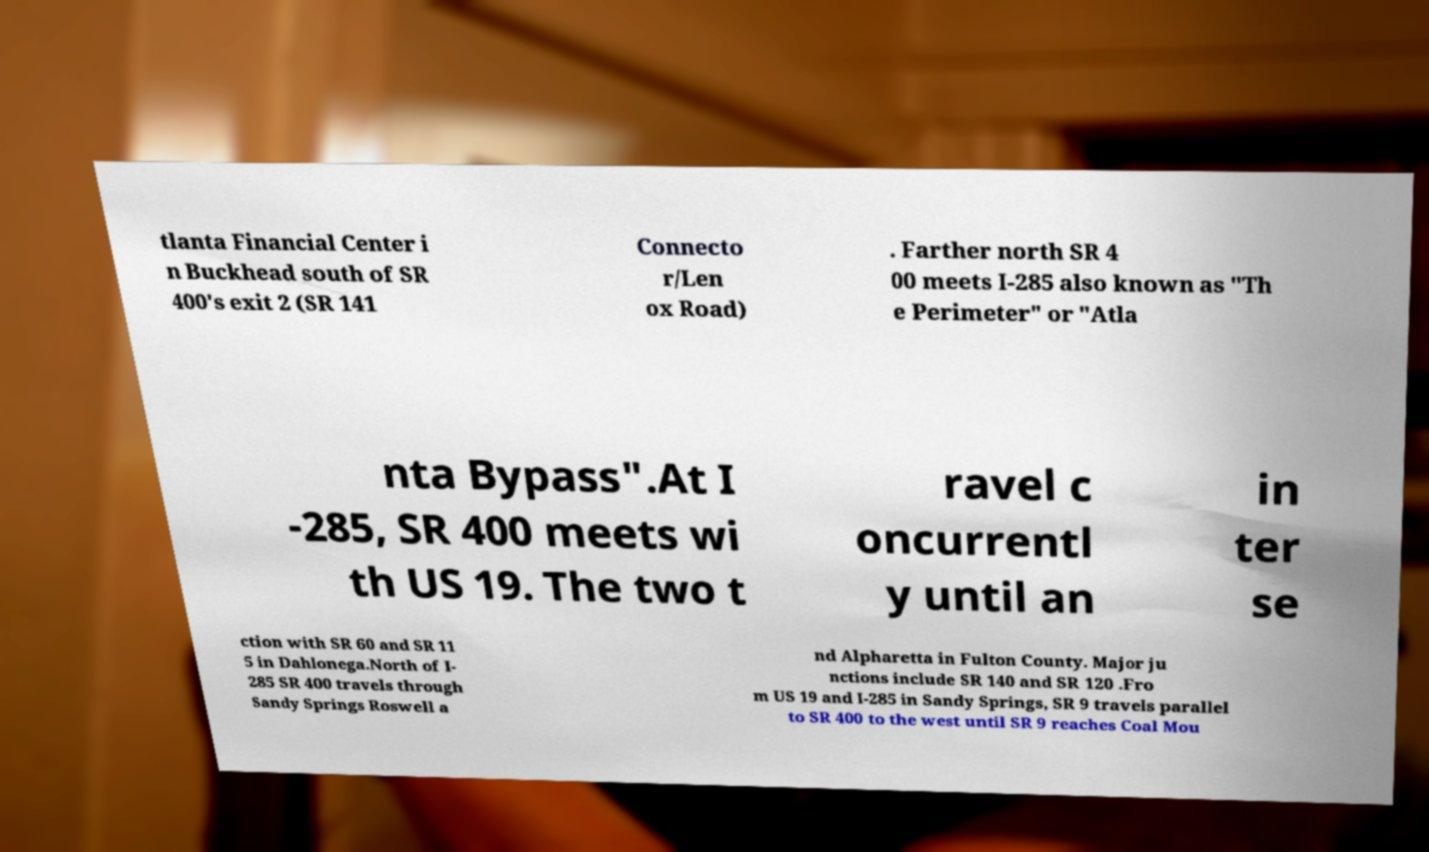For documentation purposes, I need the text within this image transcribed. Could you provide that? tlanta Financial Center i n Buckhead south of SR 400's exit 2 (SR 141 Connecto r/Len ox Road) . Farther north SR 4 00 meets I-285 also known as "Th e Perimeter" or "Atla nta Bypass".At I -285, SR 400 meets wi th US 19. The two t ravel c oncurrentl y until an in ter se ction with SR 60 and SR 11 5 in Dahlonega.North of I- 285 SR 400 travels through Sandy Springs Roswell a nd Alpharetta in Fulton County. Major ju nctions include SR 140 and SR 120 .Fro m US 19 and I-285 in Sandy Springs, SR 9 travels parallel to SR 400 to the west until SR 9 reaches Coal Mou 